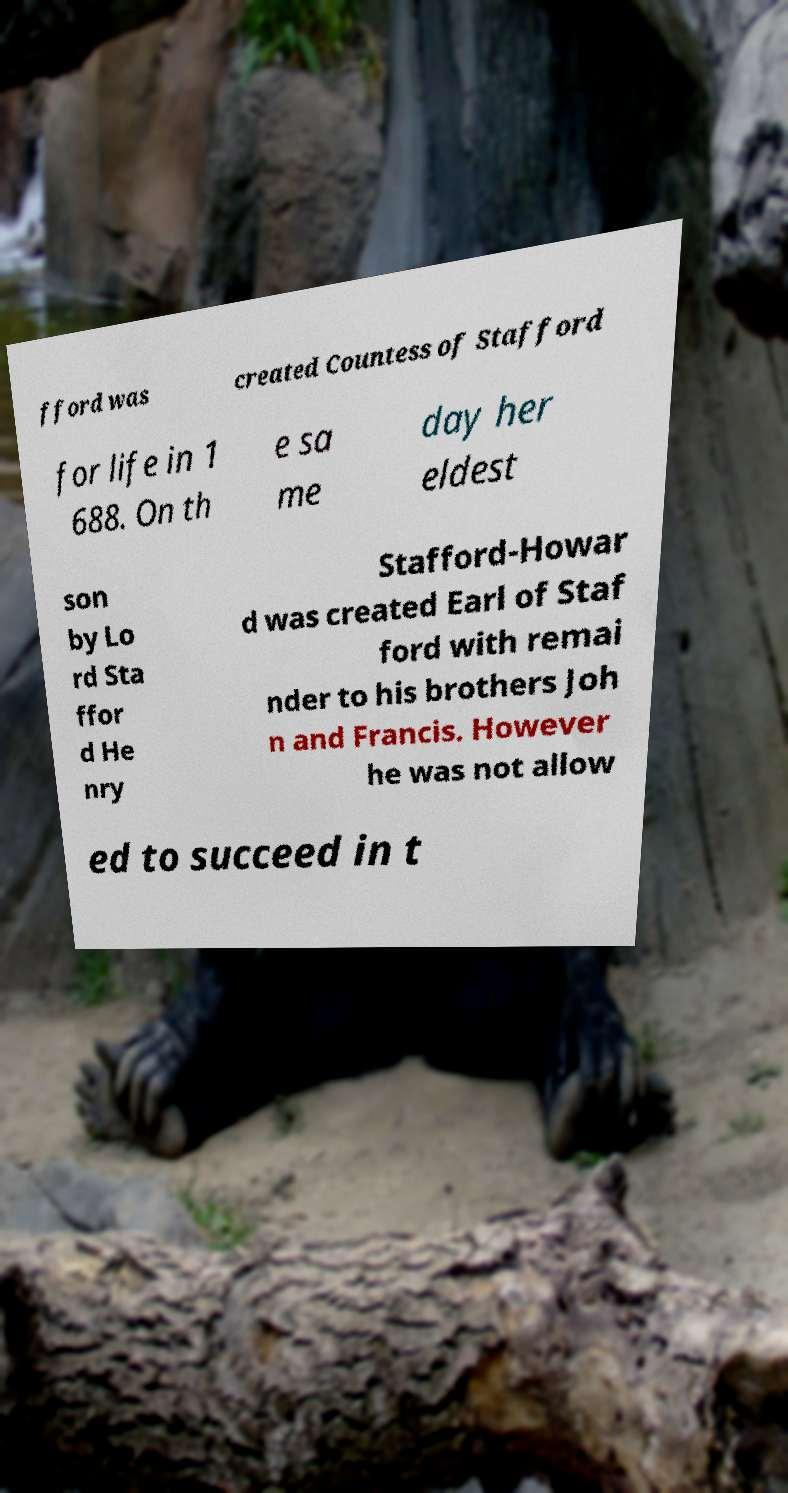For documentation purposes, I need the text within this image transcribed. Could you provide that? fford was created Countess of Stafford for life in 1 688. On th e sa me day her eldest son by Lo rd Sta ffor d He nry Stafford-Howar d was created Earl of Staf ford with remai nder to his brothers Joh n and Francis. However he was not allow ed to succeed in t 